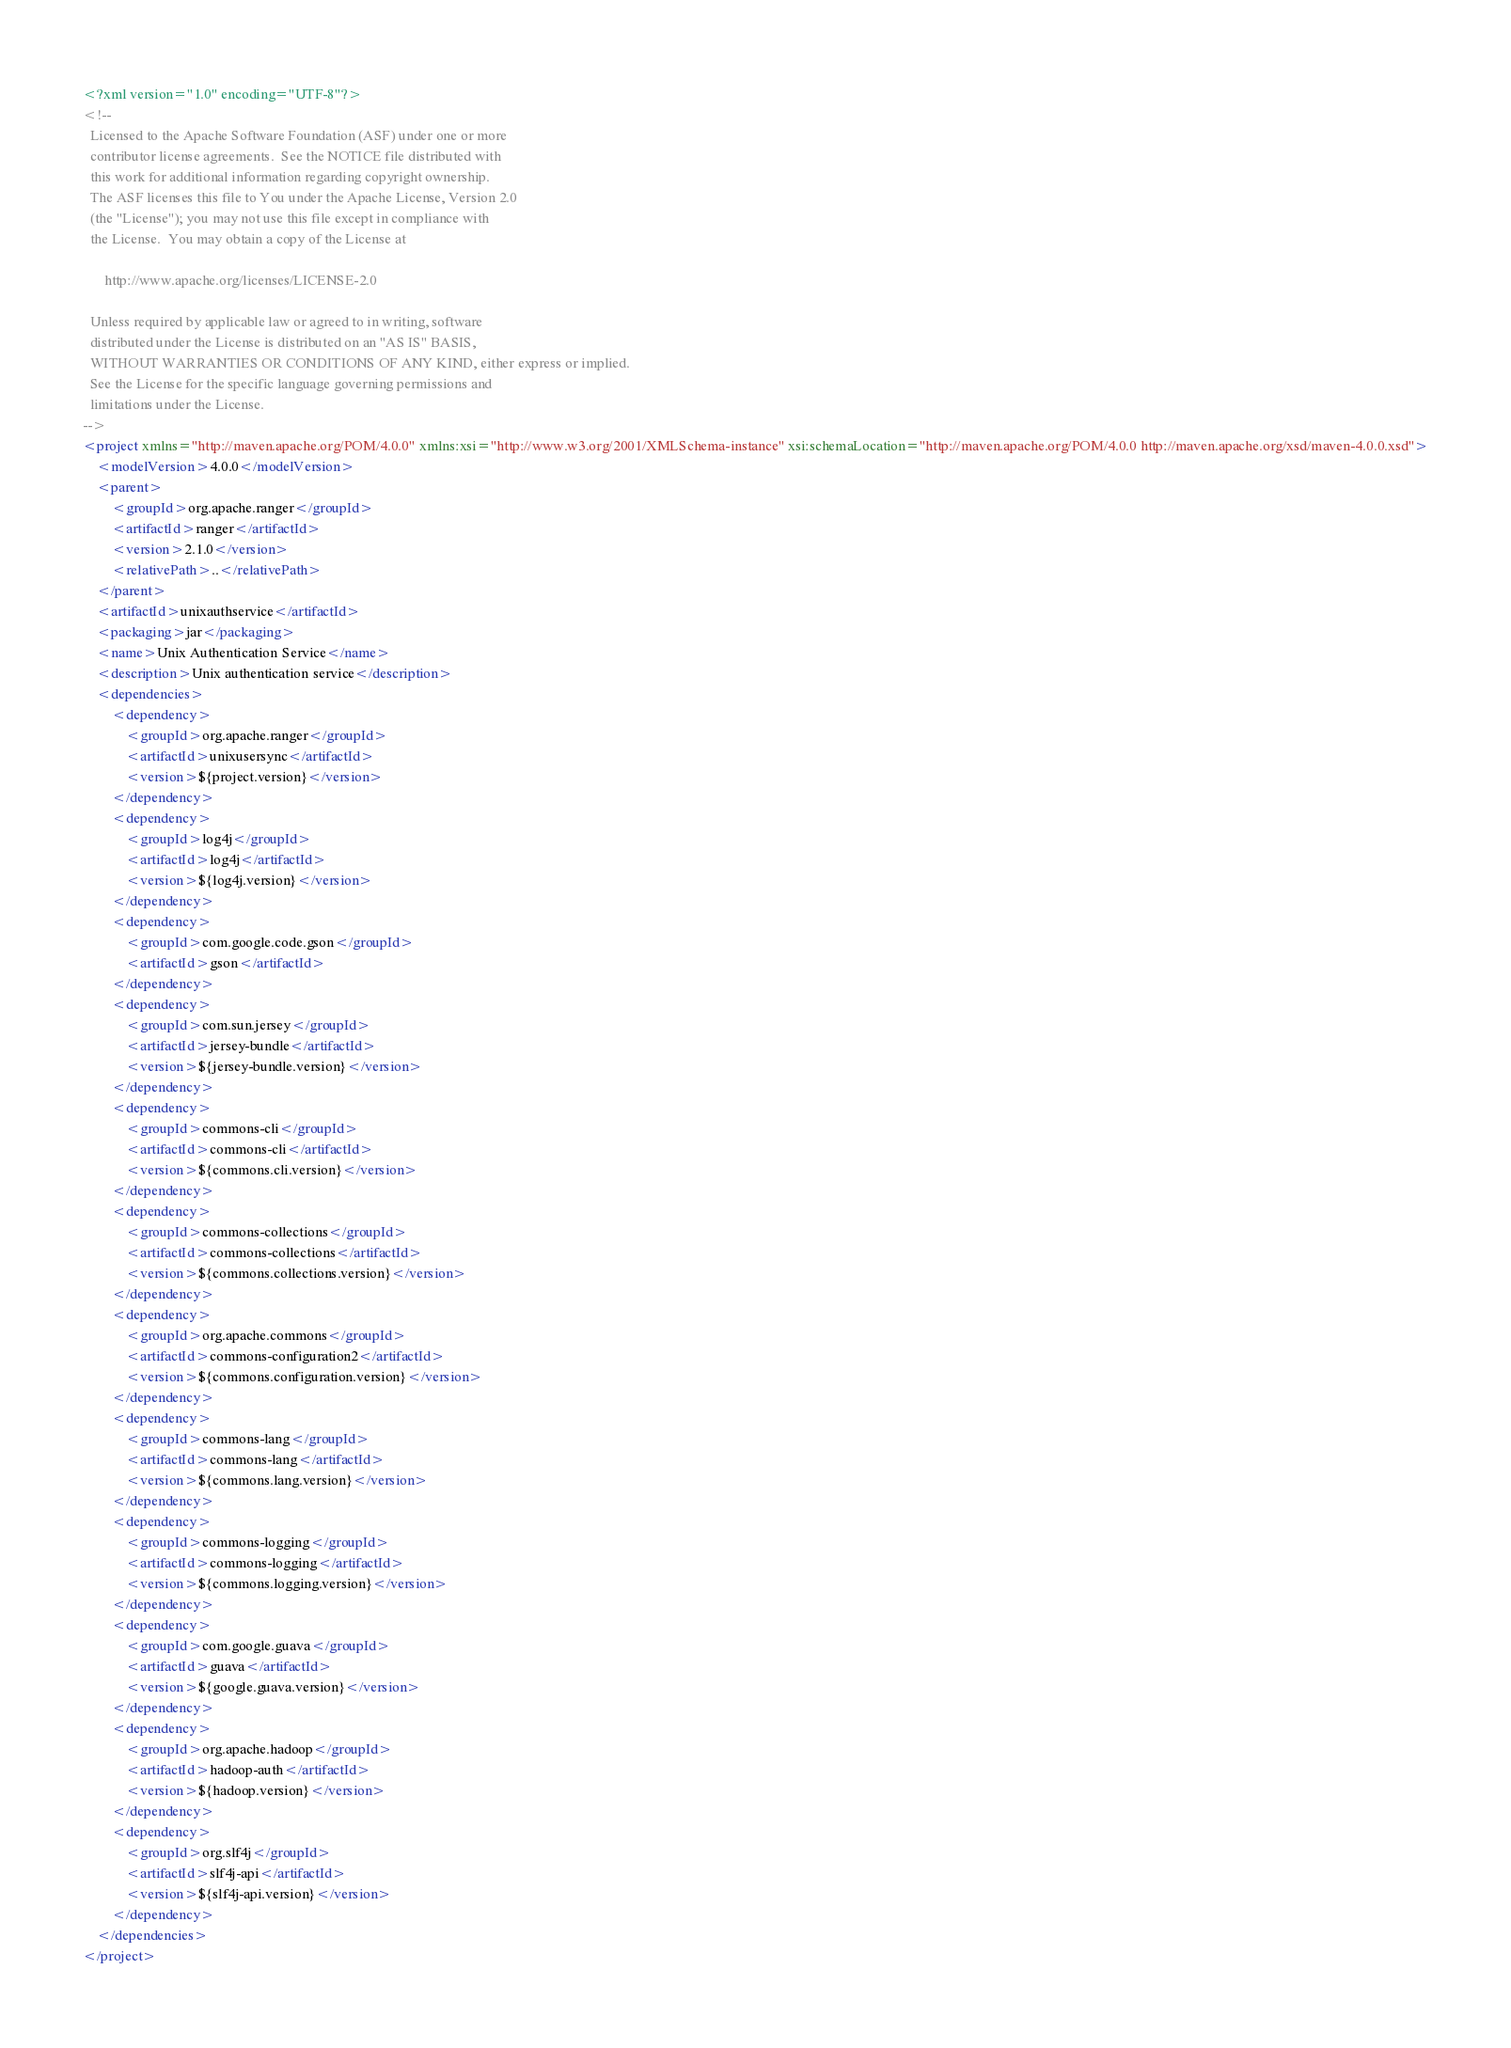<code> <loc_0><loc_0><loc_500><loc_500><_XML_><?xml version="1.0" encoding="UTF-8"?>
<!--
  Licensed to the Apache Software Foundation (ASF) under one or more
  contributor license agreements.  See the NOTICE file distributed with
  this work for additional information regarding copyright ownership.
  The ASF licenses this file to You under the Apache License, Version 2.0
  (the "License"); you may not use this file except in compliance with
  the License.  You may obtain a copy of the License at

      http://www.apache.org/licenses/LICENSE-2.0

  Unless required by applicable law or agreed to in writing, software
  distributed under the License is distributed on an "AS IS" BASIS,
  WITHOUT WARRANTIES OR CONDITIONS OF ANY KIND, either express or implied.
  See the License for the specific language governing permissions and
  limitations under the License.
-->
<project xmlns="http://maven.apache.org/POM/4.0.0" xmlns:xsi="http://www.w3.org/2001/XMLSchema-instance" xsi:schemaLocation="http://maven.apache.org/POM/4.0.0 http://maven.apache.org/xsd/maven-4.0.0.xsd">
    <modelVersion>4.0.0</modelVersion>
    <parent>
        <groupId>org.apache.ranger</groupId>
        <artifactId>ranger</artifactId>
        <version>2.1.0</version>
        <relativePath>..</relativePath>
    </parent>
    <artifactId>unixauthservice</artifactId>
    <packaging>jar</packaging>
    <name>Unix Authentication Service</name>
    <description>Unix authentication service</description>
    <dependencies>
        <dependency>
            <groupId>org.apache.ranger</groupId>
            <artifactId>unixusersync</artifactId>
            <version>${project.version}</version>
        </dependency>
        <dependency>
            <groupId>log4j</groupId>
            <artifactId>log4j</artifactId>
            <version>${log4j.version}</version>
        </dependency>
        <dependency>
            <groupId>com.google.code.gson</groupId>
            <artifactId>gson</artifactId>
        </dependency>
        <dependency>
            <groupId>com.sun.jersey</groupId>
            <artifactId>jersey-bundle</artifactId>
            <version>${jersey-bundle.version}</version>
        </dependency>
        <dependency>
            <groupId>commons-cli</groupId>
            <artifactId>commons-cli</artifactId>
            <version>${commons.cli.version}</version>
        </dependency>
        <dependency>
            <groupId>commons-collections</groupId>
            <artifactId>commons-collections</artifactId>
            <version>${commons.collections.version}</version>
        </dependency>
        <dependency>
            <groupId>org.apache.commons</groupId>
            <artifactId>commons-configuration2</artifactId>
            <version>${commons.configuration.version}</version>
        </dependency>
        <dependency>
            <groupId>commons-lang</groupId>
            <artifactId>commons-lang</artifactId>
            <version>${commons.lang.version}</version>
        </dependency>
        <dependency>
            <groupId>commons-logging</groupId>
            <artifactId>commons-logging</artifactId>
            <version>${commons.logging.version}</version>
        </dependency>
        <dependency>
            <groupId>com.google.guava</groupId>
            <artifactId>guava</artifactId>
            <version>${google.guava.version}</version>
        </dependency>
        <dependency>
            <groupId>org.apache.hadoop</groupId>
            <artifactId>hadoop-auth</artifactId>
            <version>${hadoop.version}</version>
        </dependency>
        <dependency>
            <groupId>org.slf4j</groupId>
            <artifactId>slf4j-api</artifactId>
            <version>${slf4j-api.version}</version>
        </dependency>
    </dependencies>
</project>
</code> 